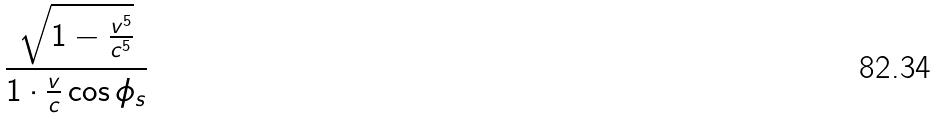<formula> <loc_0><loc_0><loc_500><loc_500>\frac { \sqrt { 1 - \frac { v ^ { 5 } } { c ^ { 5 } } } } { 1 \cdot \frac { v } { c } \cos \phi _ { s } }</formula> 